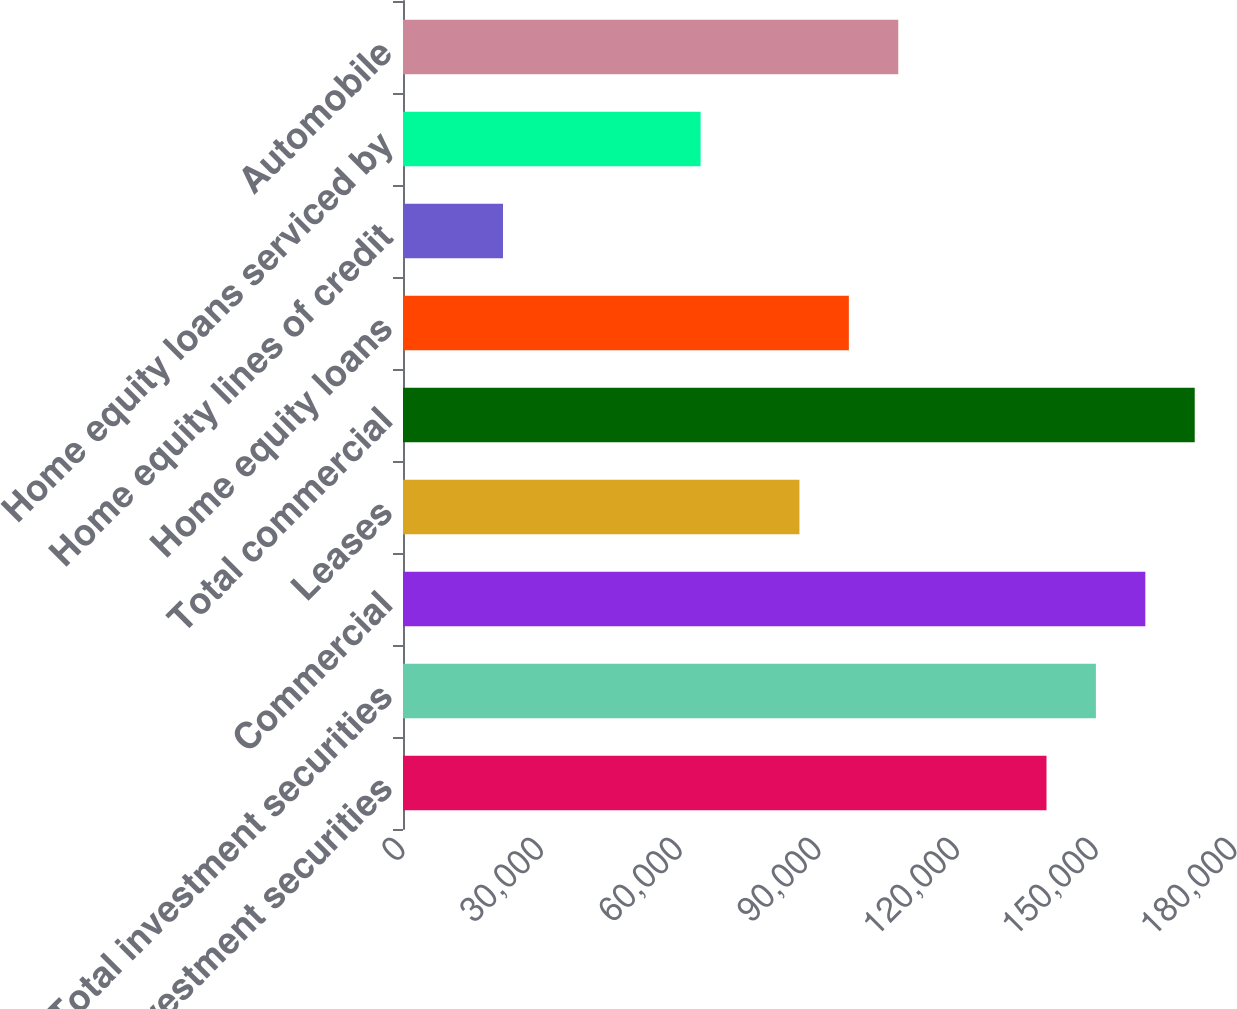Convert chart to OTSL. <chart><loc_0><loc_0><loc_500><loc_500><bar_chart><fcel>Taxable investment securities<fcel>Total investment securities<fcel>Commercial<fcel>Leases<fcel>Total commercial<fcel>Home equity loans<fcel>Home equity lines of credit<fcel>Home equity loans serviced by<fcel>Automobile<nl><fcel>139218<fcel>149908<fcel>160598<fcel>85769.4<fcel>171288<fcel>96459.2<fcel>21630.6<fcel>64389.8<fcel>107149<nl></chart> 